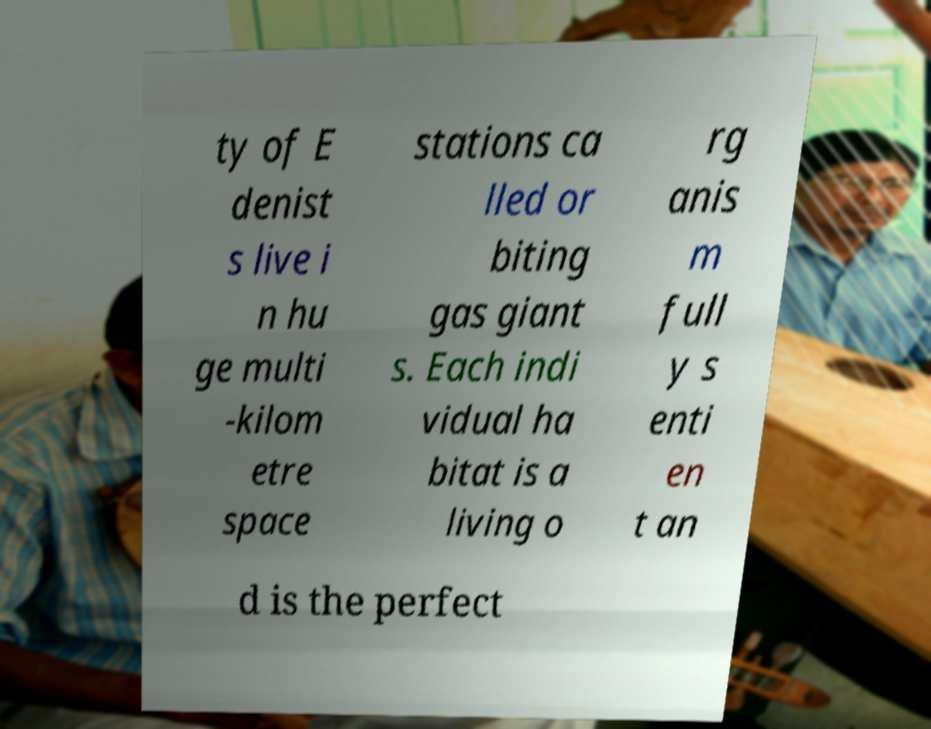Please read and relay the text visible in this image. What does it say? ty of E denist s live i n hu ge multi -kilom etre space stations ca lled or biting gas giant s. Each indi vidual ha bitat is a living o rg anis m full y s enti en t an d is the perfect 